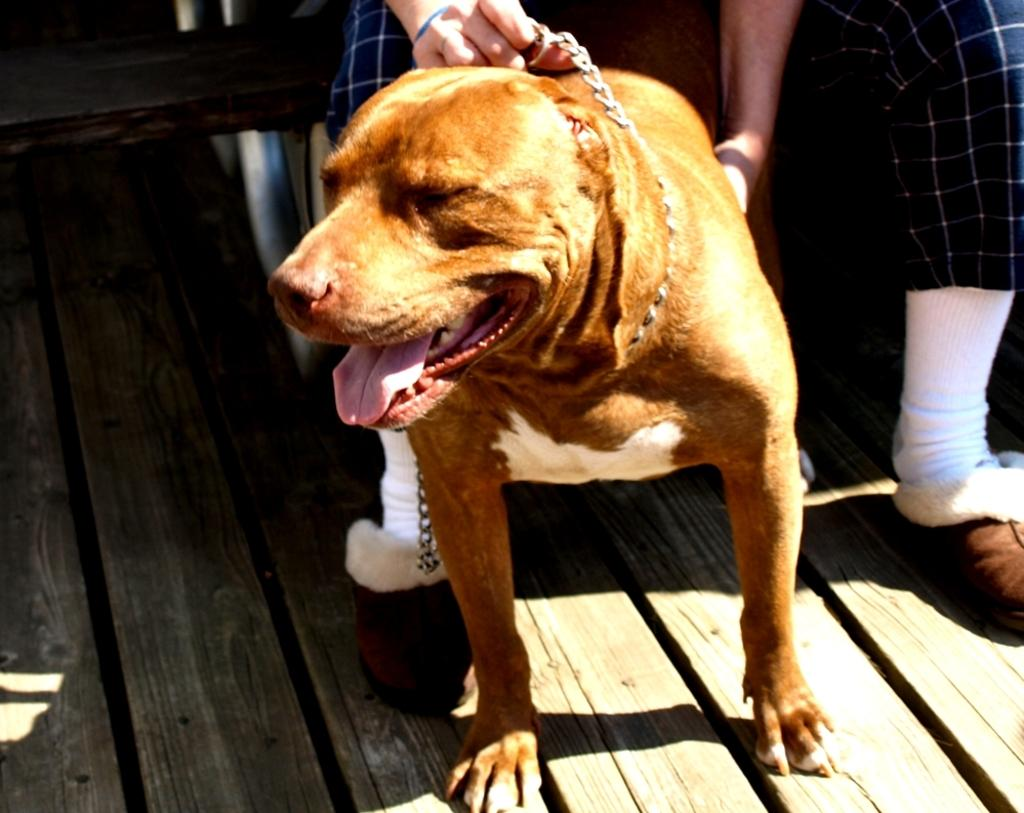What type of animal is in the image? There is a dog in the image. Where is the dog located in the image? The dog is on the floor. What can be seen in the background of the image? There is a floor and person's legs visible in the background of the image. How many toes does the dog have on its son in the image? There is no son present in the image, and dogs do not have toes on their offspring. 